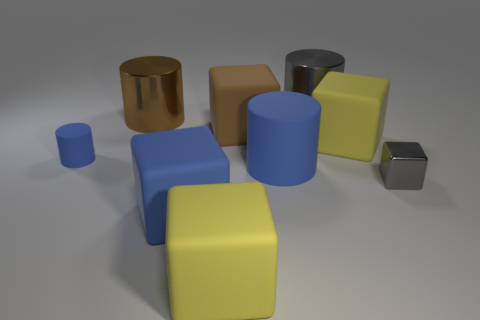How many other matte cubes have the same size as the blue cube?
Give a very brief answer. 3. There is a metal cylinder that is left of the blue rubber block; is it the same size as the yellow rubber thing that is in front of the blue block?
Ensure brevity in your answer.  Yes. Is the number of large matte things in front of the small matte cylinder greater than the number of gray blocks that are on the right side of the tiny metallic cube?
Provide a short and direct response. Yes. How many tiny gray things have the same shape as the small blue rubber object?
Your response must be concise. 0. There is a brown block that is the same size as the blue cube; what is it made of?
Ensure brevity in your answer.  Rubber. Is there a yellow block made of the same material as the brown block?
Your response must be concise. Yes. Are there fewer brown metal objects right of the gray cylinder than big purple metallic cylinders?
Offer a very short reply. No. There is a thing that is on the right side of the big matte object on the right side of the gray metal cylinder; what is its material?
Offer a very short reply. Metal. What is the shape of the shiny thing that is to the right of the large blue cylinder and in front of the large gray metal cylinder?
Provide a short and direct response. Cube. How many other things are there of the same color as the small shiny cube?
Your answer should be very brief. 1. 